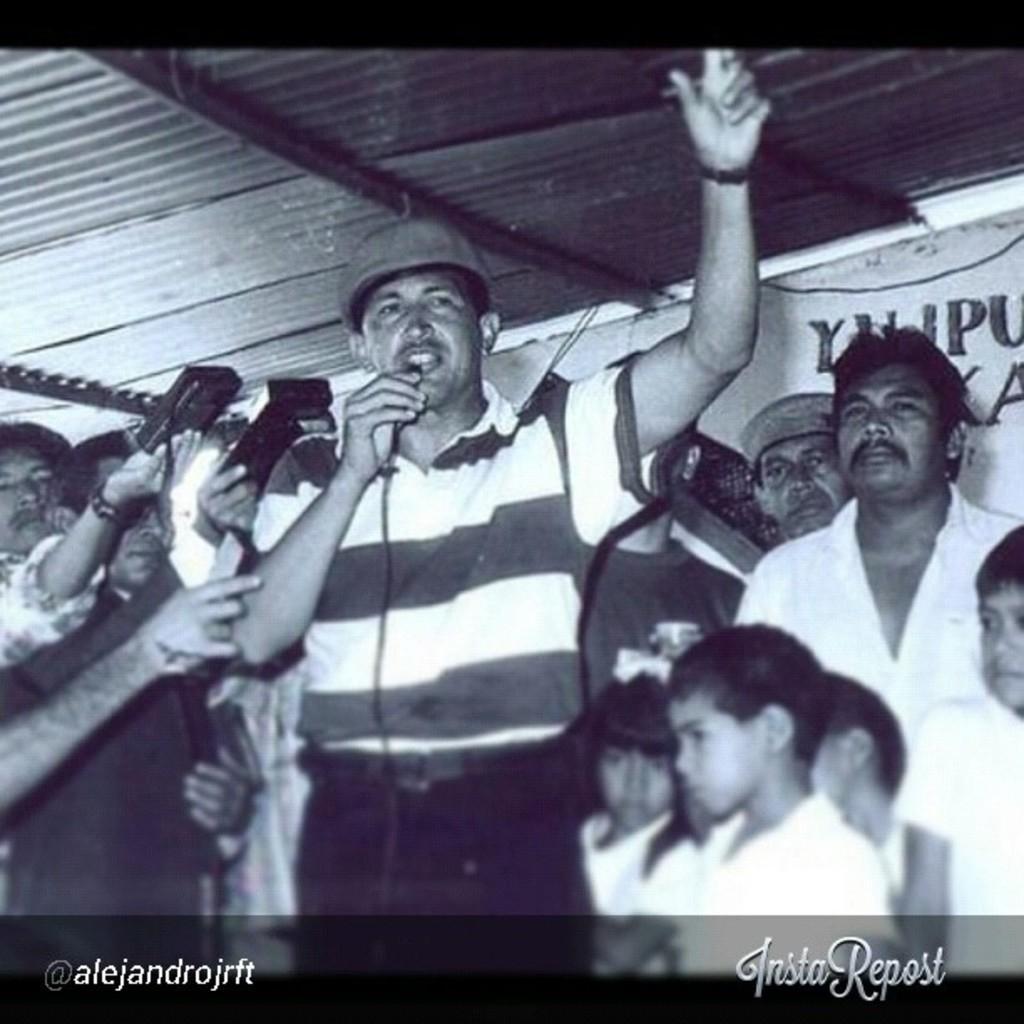In one or two sentences, can you explain what this image depicts? This is a black and white picture. The man in the middle of the picture wearing white t-shirt is holding a microphone in his hand and he is talking on the microphone. Beside him, the man in black shirt is holding a microphone. Behind him, we see people holding cameras and clicking photos on it. Behind them, we see a white wall with some text written on it and at the top of the picture, we see the roof of the room. 